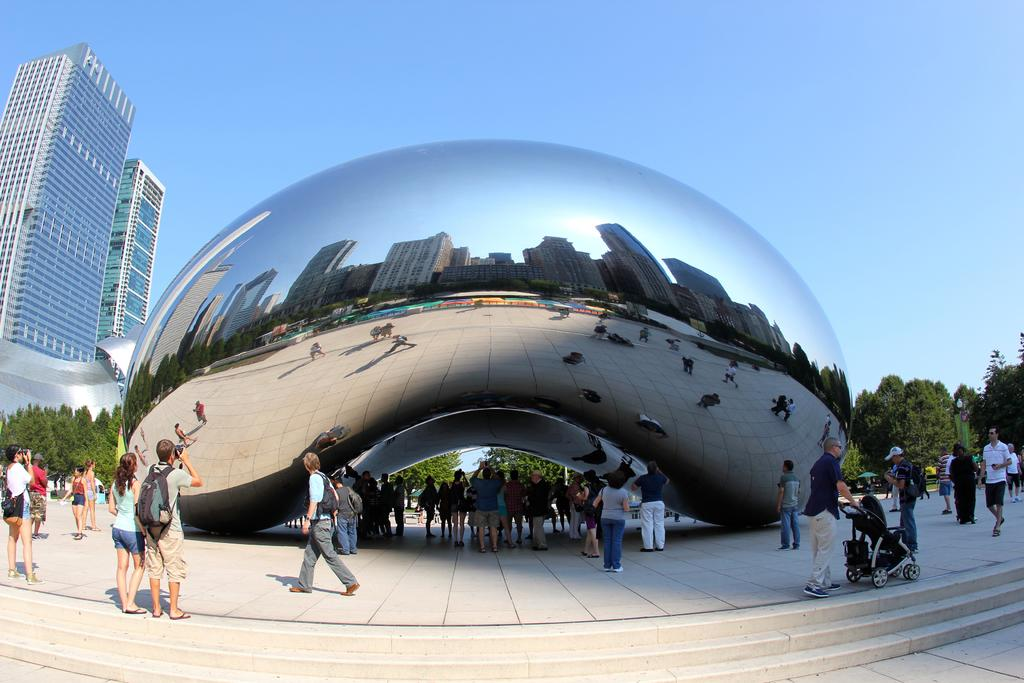What location is depicted in the image? The image depicts a view of the millennium park. What is the main feature in the image? The big mirror dome is a prominent feature in the image. What can be seen in front of the big mirror dome? There are people standing in front of the big mirror dome. What is visible in the background of the image? There are trees and buildings visible in the background. What type of tank is visible in the image? There is no tank present in the image; it depicts a view of the millennium park with the big mirror dome as the main feature. What invention is being showcased in the image? There is no specific invention being showcased in the image; it primarily features the big mirror dome and the surrounding park area. 